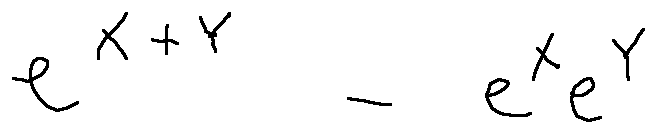Convert formula to latex. <formula><loc_0><loc_0><loc_500><loc_500>e ^ { X + Y } - e ^ { X } e ^ { Y }</formula> 